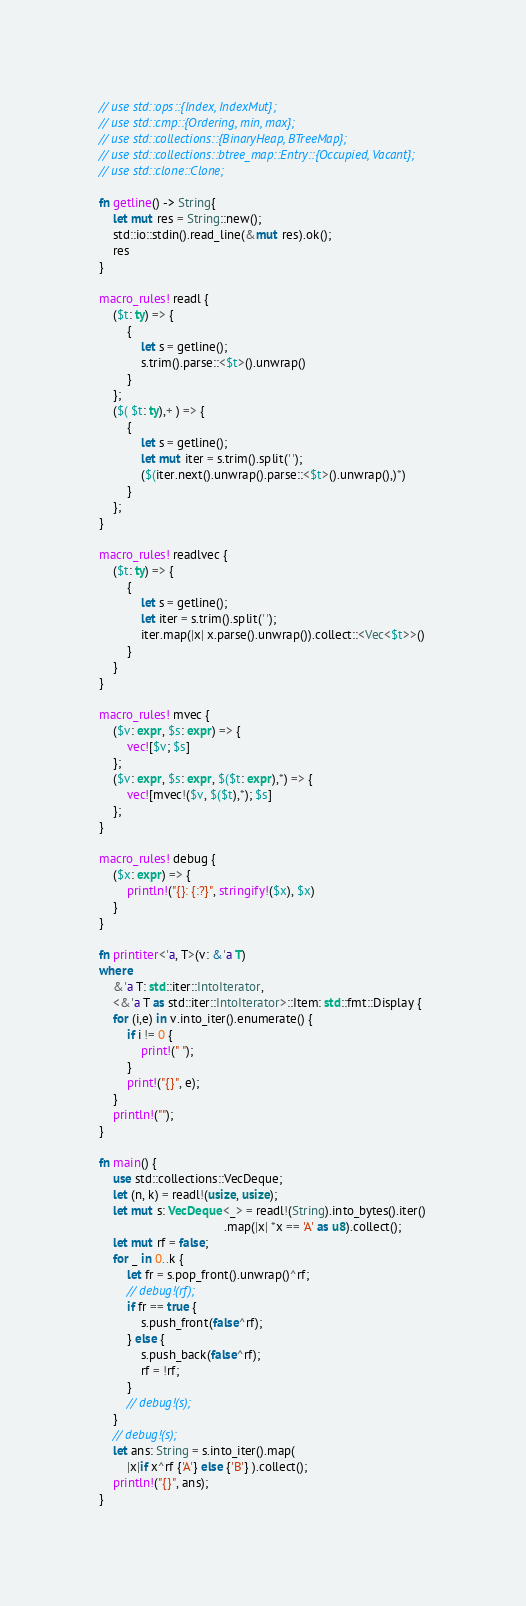Convert code to text. <code><loc_0><loc_0><loc_500><loc_500><_Rust_>// use std::ops::{Index, IndexMut};
// use std::cmp::{Ordering, min, max};
// use std::collections::{BinaryHeap, BTreeMap};
// use std::collections::btree_map::Entry::{Occupied, Vacant};
// use std::clone::Clone;

fn getline() -> String{
    let mut res = String::new();
    std::io::stdin().read_line(&mut res).ok();
    res
}

macro_rules! readl {
    ($t: ty) => {
        {
            let s = getline();
            s.trim().parse::<$t>().unwrap()
        }
    };
    ($( $t: ty),+ ) => {
        {
            let s = getline();
            let mut iter = s.trim().split(' ');
            ($(iter.next().unwrap().parse::<$t>().unwrap(),)*) 
        }
    };
}

macro_rules! readlvec {
    ($t: ty) => {
        {
            let s = getline();
            let iter = s.trim().split(' ');
            iter.map(|x| x.parse().unwrap()).collect::<Vec<$t>>()
        }
    }
}

macro_rules! mvec {
    ($v: expr, $s: expr) => {
        vec![$v; $s]
    };
    ($v: expr, $s: expr, $($t: expr),*) => {
        vec![mvec!($v, $($t),*); $s]
    };
}

macro_rules! debug {
    ($x: expr) => {
        println!("{}: {:?}", stringify!($x), $x)
    }
}

fn printiter<'a, T>(v: &'a T)
where
    &'a T: std::iter::IntoIterator, 
    <&'a T as std::iter::IntoIterator>::Item: std::fmt::Display {
    for (i,e) in v.into_iter().enumerate() {
        if i != 0 {
            print!(" ");
        }
        print!("{}", e);
    }
    println!("");
}

fn main() {
    use std::collections::VecDeque;
	let (n, k) = readl!(usize, usize);
	let mut s: VecDeque<_> = readl!(String).into_bytes().iter()
                                    .map(|x| *x == 'A' as u8).collect();
    let mut rf = false;
    for _ in 0..k {
        let fr = s.pop_front().unwrap()^rf;
        // debug!(rf);
        if fr == true {
            s.push_front(false^rf);
        } else {
            s.push_back(false^rf);
            rf = !rf;
        }
        // debug!(s);
    }
    // debug!(s);
    let ans: String = s.into_iter().map(
        |x|if x^rf {'A'} else {'B'} ).collect();
    println!("{}", ans);
}

</code> 